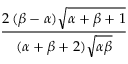Convert formula to latex. <formula><loc_0><loc_0><loc_500><loc_500>\frac { 2 \, ( \beta - \alpha ) { \sqrt { \alpha + \beta + 1 } } } { ( \alpha + \beta + 2 ) { \sqrt { \alpha \beta } } }</formula> 